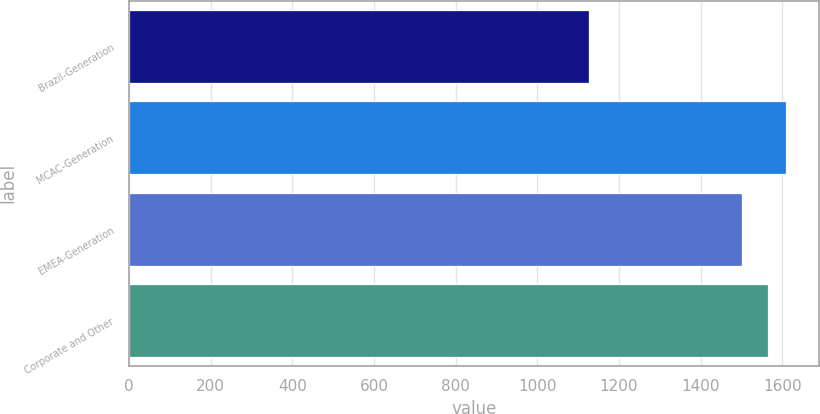Convert chart to OTSL. <chart><loc_0><loc_0><loc_500><loc_500><bar_chart><fcel>Brazil-Generation<fcel>MCAC-Generation<fcel>EMEA-Generation<fcel>Corporate and Other<nl><fcel>1128<fcel>1609.7<fcel>1501<fcel>1565<nl></chart> 